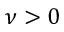<formula> <loc_0><loc_0><loc_500><loc_500>\nu > 0</formula> 